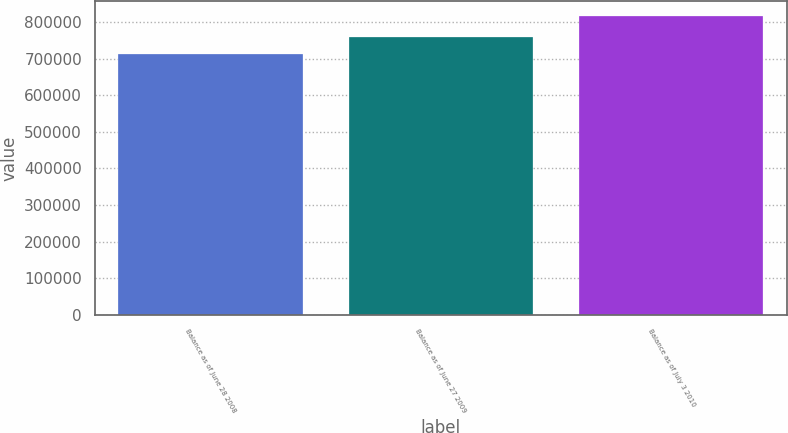Convert chart. <chart><loc_0><loc_0><loc_500><loc_500><bar_chart><fcel>Balance as of June 28 2008<fcel>Balance as of June 27 2009<fcel>Balance as of July 3 2010<nl><fcel>712208<fcel>760352<fcel>816833<nl></chart> 